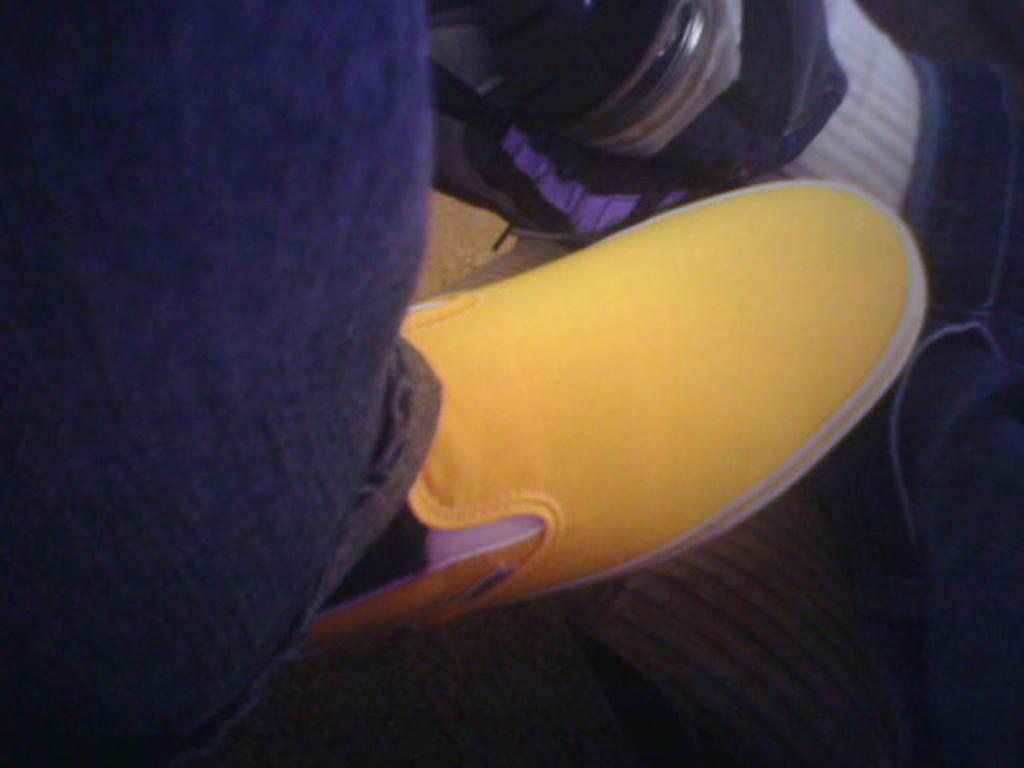What part of a person's body is visible in the image? There is a person's leg in the image. What color is the shoe on the person's leg? The person's leg has a yellow shoe. What type of destruction is being caused by the bat in the image? There is no bat or destruction present in the image; it only features a person's leg with a yellow shoe. 